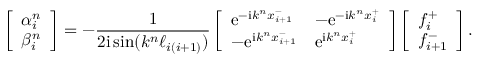<formula> <loc_0><loc_0><loc_500><loc_500>\left [ \begin{array} { l } { \alpha _ { i } ^ { n } } \\ { \beta _ { i } ^ { n } } \end{array} \right ] = - \frac { 1 } { 2 i \sin ( k ^ { n } \ell _ { i ( i + 1 ) } ) } \left [ \begin{array} { l l } { e ^ { - i k ^ { n } x _ { i + 1 } ^ { - } } } & { - e ^ { - i k ^ { n } x _ { i } ^ { + } } } \\ { - e ^ { i k ^ { n } x _ { i + 1 } ^ { - } } } & { e ^ { i k ^ { n } x _ { i } ^ { + } } } \end{array} \right ] \left [ \begin{array} { l } { f _ { i } ^ { + } } \\ { f _ { i + 1 } ^ { - } } \end{array} \right ] .</formula> 